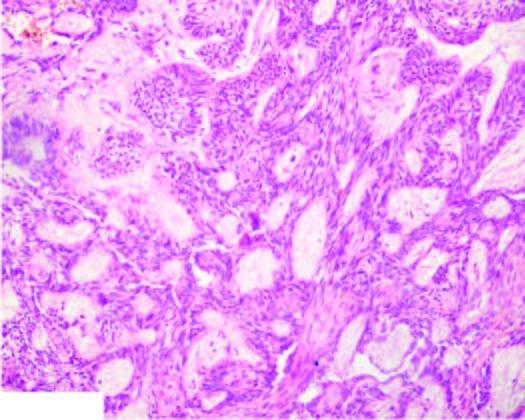do the alveolar walls show irregular plexiform masses and network of strands of epithelial cells?
Answer the question using a single word or phrase. No 